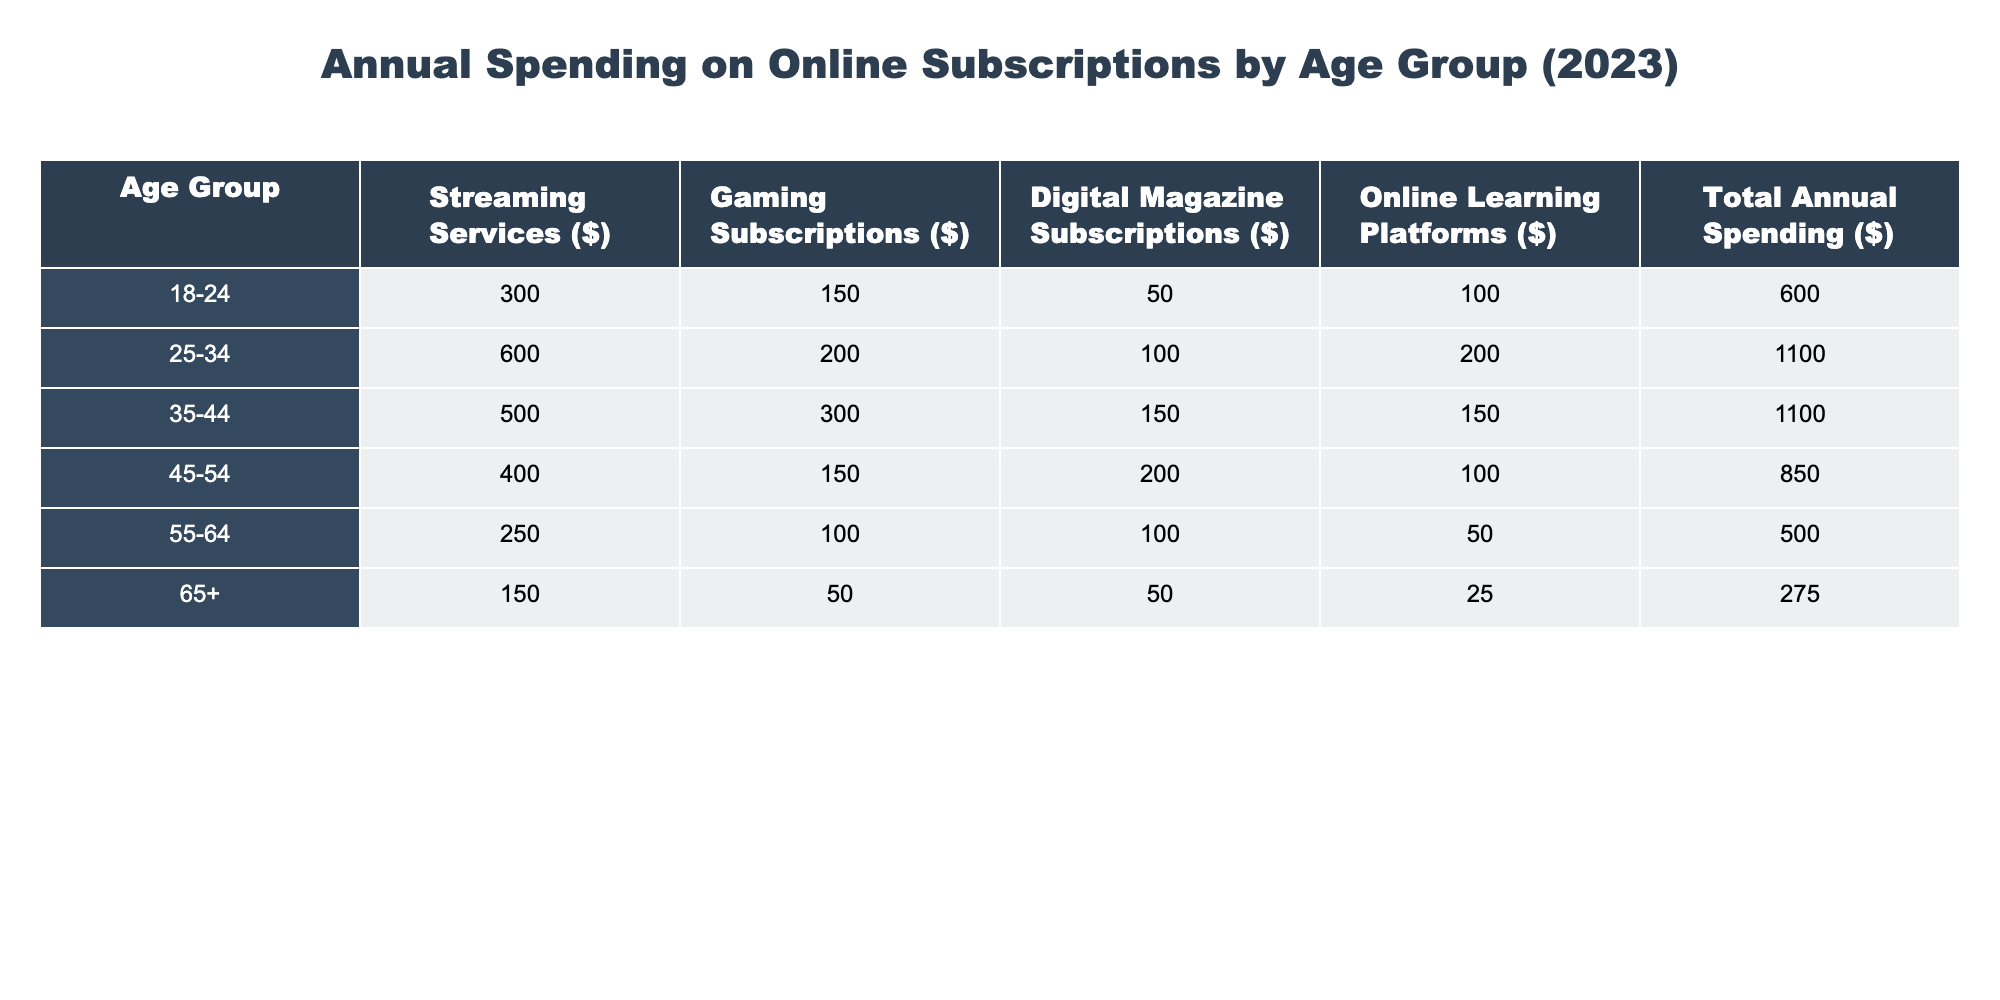What is the total annual spending for the age group 35-44? From the table, the total annual spending for the age group 35-44 is already provided as 1100.
Answer: 1100 Which age group spends the least on streaming services? By examining the streaming services column, the age group 65+ has the lowest spending at 150.
Answer: 65+ What is the average annual spending across all age groups? To find the average, we sum the total spending (600 + 1100 + 1100 + 850 + 500 + 275 = 4425) and divide by the number of age groups (6). So, 4425 / 6 = 737.5.
Answer: 737.5 Do people aged 55-64 spend more on gaming subscriptions than those aged 65+? According to the table, people aged 55-64 spend 100 on gaming subscriptions, while those aged 65+ spend only 50. Thus, 100 is greater than 50.
Answer: Yes What is the difference in total annual spending between the age groups 25-34 and 45-54? The total for 25-34 is 1100 and for 45-54 is 850. The difference is 1100 - 850 = 250.
Answer: 250 Which age group has the highest spending on online learning platforms? Checking the online learning platforms column, the age group 25-34 spends the most at 200.
Answer: 25-34 How much do individuals aged 18-24 spend on digital magazine subscriptions compared to those aged 55-64? The age group 18-24 spends 50 on digital magazine subscriptions, whereas 55-64 spends 100. Comparing these values: 50 is less than 100, so 18-24 spends less.
Answer: Less What is the total spending on gaming subscriptions for all age groups combined? We can calculate this by adding the gaming subscription values: 150 + 200 + 300 + 150 + 100 + 50 = 1050.
Answer: 1050 Is the total annual spending for the age group 65+ greater than the total for the age group 55-64? The total for 65+ is 275, and for 55-64 it is 500. Since 275 is less than 500, the answer is no.
Answer: No What can be inferred about the spending trends of older age groups compared to younger age groups? By comparing the overall spending, we see that younger age groups (18-24, 25-34) tend to spend more on online subscriptions than older age groups (55-64, 65+), suggesting a trend of higher spending in younger demographics.
Answer: Younger age groups spend more 